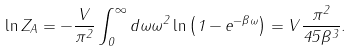Convert formula to latex. <formula><loc_0><loc_0><loc_500><loc_500>\ln Z _ { A } = - \frac { V } { \pi ^ { 2 } } \int _ { 0 } ^ { \infty } d \omega \omega ^ { 2 } \ln \left ( 1 - e ^ { - \beta \omega } \right ) = V \frac { \pi ^ { 2 } } { 4 5 \beta ^ { 3 } } .</formula> 